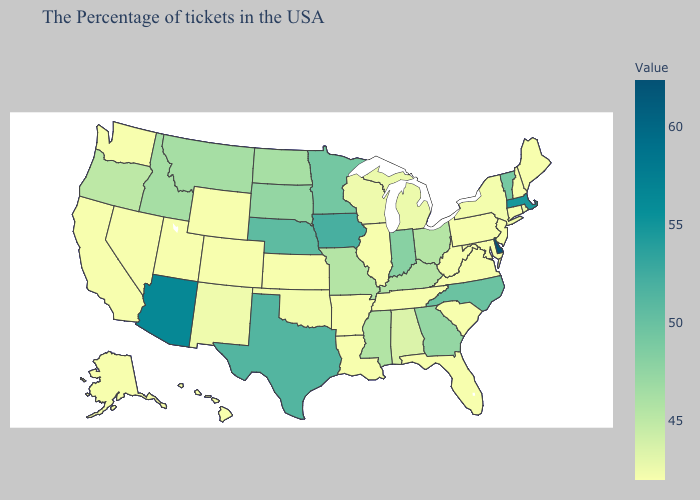Does Hawaii have the highest value in the USA?
Be succinct. No. 